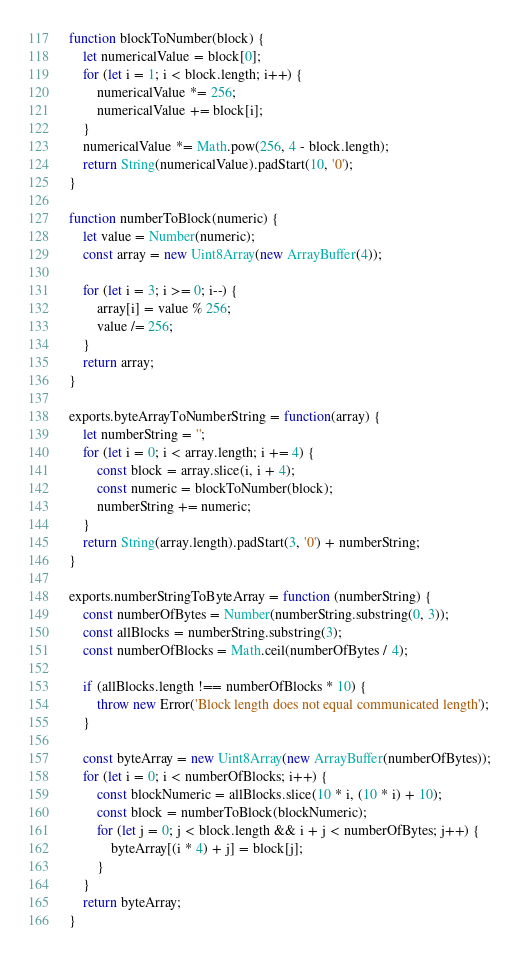Convert code to text. <code><loc_0><loc_0><loc_500><loc_500><_JavaScript_>function blockToNumber(block) {
    let numericalValue = block[0];
    for (let i = 1; i < block.length; i++) {
        numericalValue *= 256;
        numericalValue += block[i];
    }
    numericalValue *= Math.pow(256, 4 - block.length);
    return String(numericalValue).padStart(10, '0');
}

function numberToBlock(numeric) {
    let value = Number(numeric);
    const array = new Uint8Array(new ArrayBuffer(4));

    for (let i = 3; i >= 0; i--) {
        array[i] = value % 256;
        value /= 256;
    }
    return array;
}

exports.byteArrayToNumberString = function(array) {
    let numberString = '';
    for (let i = 0; i < array.length; i += 4) {
        const block = array.slice(i, i + 4);
        const numeric = blockToNumber(block);
        numberString += numeric;
    }
    return String(array.length).padStart(3, '0') + numberString;
}

exports.numberStringToByteArray = function (numberString) {
    const numberOfBytes = Number(numberString.substring(0, 3));
    const allBlocks = numberString.substring(3);
    const numberOfBlocks = Math.ceil(numberOfBytes / 4);

    if (allBlocks.length !== numberOfBlocks * 10) {
        throw new Error('Block length does not equal communicated length');
    }

    const byteArray = new Uint8Array(new ArrayBuffer(numberOfBytes));
    for (let i = 0; i < numberOfBlocks; i++) {
        const blockNumeric = allBlocks.slice(10 * i, (10 * i) + 10);
        const block = numberToBlock(blockNumeric);
        for (let j = 0; j < block.length && i + j < numberOfBytes; j++) {
            byteArray[(i * 4) + j] = block[j];
        }
    }
    return byteArray;
}
</code> 